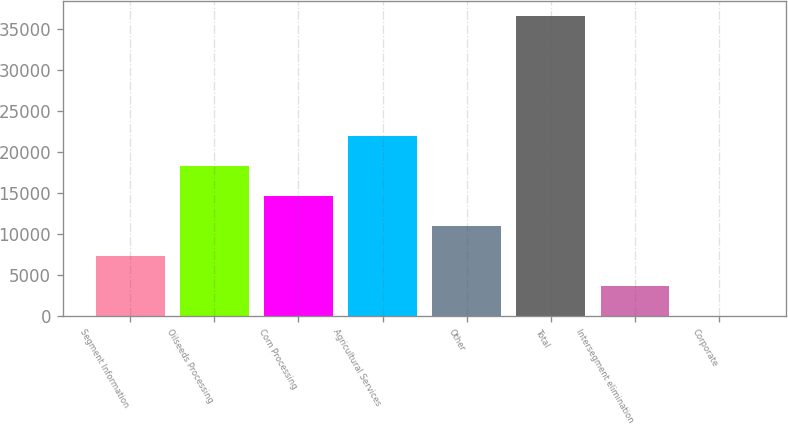<chart> <loc_0><loc_0><loc_500><loc_500><bar_chart><fcel>Segment Information<fcel>Oilseeds Processing<fcel>Corn Processing<fcel>Agricultural Services<fcel>Other<fcel>Total<fcel>Intersegment elimination<fcel>Corporate<nl><fcel>7338.4<fcel>18310<fcel>14652.8<fcel>21967.2<fcel>10995.6<fcel>36596<fcel>3681.2<fcel>24<nl></chart> 